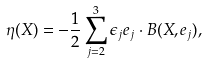<formula> <loc_0><loc_0><loc_500><loc_500>\eta ( X ) = - \frac { 1 } { 2 } \sum _ { j = 2 } ^ { 3 } \epsilon _ { j } e _ { j } \cdot B ( X , e _ { j } ) ,</formula> 